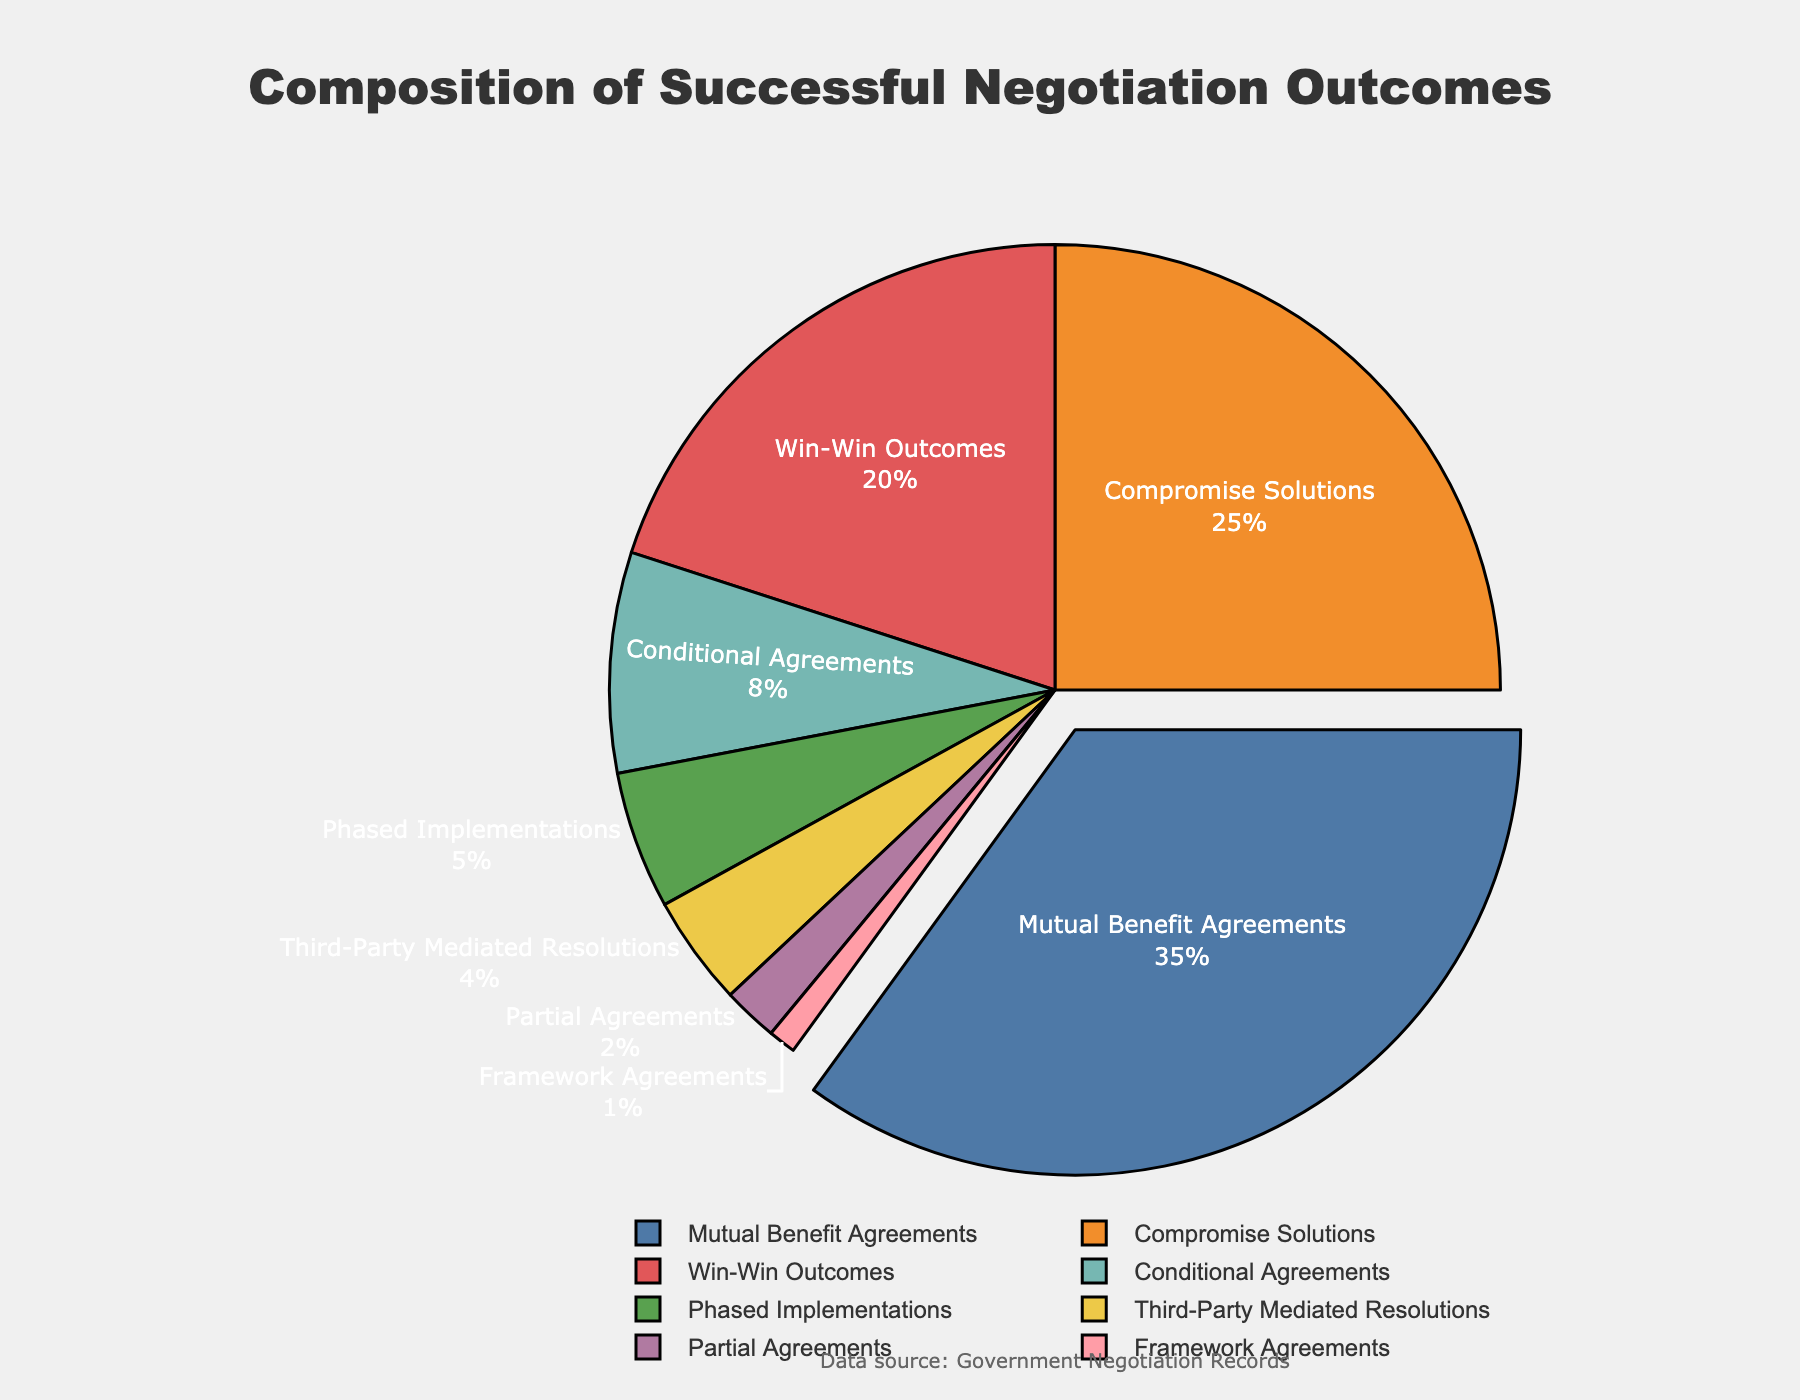What is the combined percentage of Mutual Benefit Agreements and Win-Win Outcomes? To find the combined percentage, add the percentages of Mutual Benefit Agreements (35%) and Win-Win Outcomes (20%): 35% + 20% = 55%
Answer: 55% Which type of agreement has the smallest percentage? By examining the figure, it's clear that Framework Agreements have the smallest segment, representing only 1% of the total
Answer: Framework Agreements Is the percentage of Compromise Solutions greater than Conditional Agreements and Phased Implementations combined? To determine this, first combine the percentages of Conditional Agreements (8%) and Phased Implementations (5%): 8% + 5% = 13%. Then compare this with the percentage of Compromise Solutions (25%): 25% > 13%, so yes it is greater
Answer: Yes Which type represents 20% of the negotiation outcomes? By looking at the figure, the type that represents 20% is Win-Win Outcomes
Answer: Win-Win Outcomes What is the difference in percentage between Third-Party Mediated Resolutions and Partial Agreements? Subtract the percentage of Partial Agreements (2%) from Third-Party Mediated Resolutions (4%): 4% - 2% = 2%
Answer: 2% Identify the types with percentages less than 10%. The types with percentages less than 10% are Conditional Agreements (8%), Phased Implementations (5%), Third-Party Mediated Resolutions (4%), Partial Agreements (2%), and Framework Agreements (1%)
Answer: Conditional Agreements, Phased Implementations, Third-Party Mediated Resolutions, Partial Agreements, Framework Agreements Which segment is colored blue in the pie chart? The segment colored blue represents Mutual Benefit Agreements. This is evident from the visual attribute of the chart, where blue corresponds to the largest section, Mutual Benefit Agreements at 35%
Answer: Mutual Benefit Agreements Arrange the types of agreements in ascending order of their percentage representation. By arranging the percentages in ascending order: Framework Agreements (1%), Partial Agreements (2%), Third-Party Mediated Resolutions (4%), Phased Implementations (5%), Conditional Agreements (8%), Win-Win Outcomes (20%), Compromise Solutions (25%), Mutual Benefit Agreements (35%)
Answer: Framework Agreements, Partial Agreements, Third-Party Mediated Resolutions, Phased Implementations, Conditional Agreements, Win-Win Outcomes, Compromise Solutions, Mutual Benefit Agreements What is the difference in percentage between the largest and the smallest segments? To find this, subtract the smallest percentage (Framework Agreements at 1%) from the largest (Mutual Benefit Agreements at 35%): 35% - 1% = 34%
Answer: 34% 